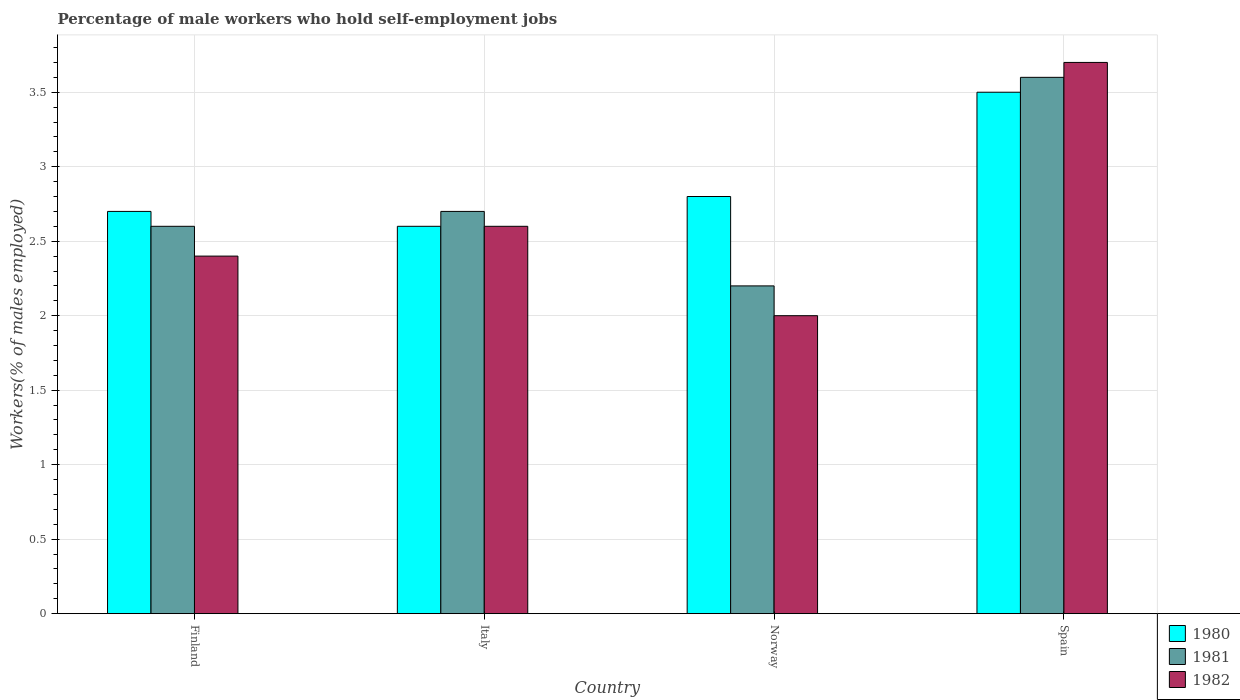How many different coloured bars are there?
Give a very brief answer. 3. Are the number of bars on each tick of the X-axis equal?
Ensure brevity in your answer.  Yes. What is the percentage of self-employed male workers in 1980 in Finland?
Offer a very short reply. 2.7. Across all countries, what is the maximum percentage of self-employed male workers in 1980?
Offer a very short reply. 3.5. Across all countries, what is the minimum percentage of self-employed male workers in 1980?
Your answer should be very brief. 2.6. In which country was the percentage of self-employed male workers in 1981 maximum?
Provide a succinct answer. Spain. What is the total percentage of self-employed male workers in 1982 in the graph?
Provide a short and direct response. 10.7. What is the difference between the percentage of self-employed male workers in 1981 in Italy and that in Spain?
Your answer should be compact. -0.9. What is the difference between the percentage of self-employed male workers in 1982 in Italy and the percentage of self-employed male workers in 1980 in Finland?
Provide a succinct answer. -0.1. What is the average percentage of self-employed male workers in 1982 per country?
Offer a very short reply. 2.68. What is the difference between the percentage of self-employed male workers of/in 1980 and percentage of self-employed male workers of/in 1982 in Finland?
Your answer should be very brief. 0.3. What is the ratio of the percentage of self-employed male workers in 1980 in Norway to that in Spain?
Keep it short and to the point. 0.8. Is the percentage of self-employed male workers in 1982 in Italy less than that in Norway?
Your response must be concise. No. What is the difference between the highest and the second highest percentage of self-employed male workers in 1980?
Give a very brief answer. -0.1. What is the difference between the highest and the lowest percentage of self-employed male workers in 1981?
Offer a terse response. 1.4. In how many countries, is the percentage of self-employed male workers in 1981 greater than the average percentage of self-employed male workers in 1981 taken over all countries?
Provide a succinct answer. 1. What does the 1st bar from the left in Spain represents?
Give a very brief answer. 1980. What does the 3rd bar from the right in Spain represents?
Ensure brevity in your answer.  1980. How many bars are there?
Your answer should be compact. 12. Are all the bars in the graph horizontal?
Your answer should be very brief. No. How many countries are there in the graph?
Your answer should be very brief. 4. What is the difference between two consecutive major ticks on the Y-axis?
Ensure brevity in your answer.  0.5. Are the values on the major ticks of Y-axis written in scientific E-notation?
Provide a short and direct response. No. Where does the legend appear in the graph?
Give a very brief answer. Bottom right. How are the legend labels stacked?
Provide a short and direct response. Vertical. What is the title of the graph?
Your answer should be compact. Percentage of male workers who hold self-employment jobs. Does "1972" appear as one of the legend labels in the graph?
Provide a succinct answer. No. What is the label or title of the Y-axis?
Keep it short and to the point. Workers(% of males employed). What is the Workers(% of males employed) in 1980 in Finland?
Offer a very short reply. 2.7. What is the Workers(% of males employed) of 1981 in Finland?
Provide a succinct answer. 2.6. What is the Workers(% of males employed) in 1982 in Finland?
Your answer should be very brief. 2.4. What is the Workers(% of males employed) of 1980 in Italy?
Your response must be concise. 2.6. What is the Workers(% of males employed) of 1981 in Italy?
Your answer should be compact. 2.7. What is the Workers(% of males employed) of 1982 in Italy?
Keep it short and to the point. 2.6. What is the Workers(% of males employed) in 1980 in Norway?
Give a very brief answer. 2.8. What is the Workers(% of males employed) in 1981 in Norway?
Offer a terse response. 2.2. What is the Workers(% of males employed) of 1982 in Norway?
Your answer should be compact. 2. What is the Workers(% of males employed) in 1981 in Spain?
Provide a short and direct response. 3.6. What is the Workers(% of males employed) in 1982 in Spain?
Your answer should be very brief. 3.7. Across all countries, what is the maximum Workers(% of males employed) in 1981?
Offer a terse response. 3.6. Across all countries, what is the maximum Workers(% of males employed) in 1982?
Keep it short and to the point. 3.7. Across all countries, what is the minimum Workers(% of males employed) of 1980?
Your answer should be compact. 2.6. Across all countries, what is the minimum Workers(% of males employed) in 1981?
Ensure brevity in your answer.  2.2. Across all countries, what is the minimum Workers(% of males employed) in 1982?
Your answer should be compact. 2. What is the total Workers(% of males employed) in 1981 in the graph?
Your answer should be very brief. 11.1. What is the total Workers(% of males employed) in 1982 in the graph?
Make the answer very short. 10.7. What is the difference between the Workers(% of males employed) in 1981 in Finland and that in Italy?
Keep it short and to the point. -0.1. What is the difference between the Workers(% of males employed) in 1980 in Finland and that in Norway?
Make the answer very short. -0.1. What is the difference between the Workers(% of males employed) in 1982 in Finland and that in Norway?
Your answer should be very brief. 0.4. What is the difference between the Workers(% of males employed) in 1980 in Finland and that in Spain?
Ensure brevity in your answer.  -0.8. What is the difference between the Workers(% of males employed) of 1981 in Finland and that in Spain?
Offer a very short reply. -1. What is the difference between the Workers(% of males employed) of 1982 in Finland and that in Spain?
Offer a terse response. -1.3. What is the difference between the Workers(% of males employed) in 1980 in Italy and that in Spain?
Your answer should be very brief. -0.9. What is the difference between the Workers(% of males employed) in 1981 in Italy and that in Spain?
Make the answer very short. -0.9. What is the difference between the Workers(% of males employed) of 1982 in Italy and that in Spain?
Provide a short and direct response. -1.1. What is the difference between the Workers(% of males employed) in 1980 in Norway and that in Spain?
Your answer should be very brief. -0.7. What is the difference between the Workers(% of males employed) of 1981 in Norway and that in Spain?
Give a very brief answer. -1.4. What is the difference between the Workers(% of males employed) in 1982 in Norway and that in Spain?
Your answer should be very brief. -1.7. What is the difference between the Workers(% of males employed) of 1980 in Finland and the Workers(% of males employed) of 1981 in Norway?
Your response must be concise. 0.5. What is the difference between the Workers(% of males employed) in 1980 in Finland and the Workers(% of males employed) in 1982 in Norway?
Offer a terse response. 0.7. What is the difference between the Workers(% of males employed) in 1981 in Finland and the Workers(% of males employed) in 1982 in Norway?
Provide a short and direct response. 0.6. What is the difference between the Workers(% of males employed) in 1980 in Finland and the Workers(% of males employed) in 1981 in Spain?
Your response must be concise. -0.9. What is the difference between the Workers(% of males employed) in 1980 in Finland and the Workers(% of males employed) in 1982 in Spain?
Keep it short and to the point. -1. What is the difference between the Workers(% of males employed) of 1981 in Italy and the Workers(% of males employed) of 1982 in Norway?
Keep it short and to the point. 0.7. What is the difference between the Workers(% of males employed) in 1981 in Italy and the Workers(% of males employed) in 1982 in Spain?
Offer a very short reply. -1. What is the difference between the Workers(% of males employed) in 1980 in Norway and the Workers(% of males employed) in 1981 in Spain?
Provide a succinct answer. -0.8. What is the difference between the Workers(% of males employed) in 1980 in Norway and the Workers(% of males employed) in 1982 in Spain?
Provide a succinct answer. -0.9. What is the difference between the Workers(% of males employed) in 1981 in Norway and the Workers(% of males employed) in 1982 in Spain?
Your answer should be compact. -1.5. What is the average Workers(% of males employed) of 1981 per country?
Provide a succinct answer. 2.77. What is the average Workers(% of males employed) of 1982 per country?
Ensure brevity in your answer.  2.67. What is the difference between the Workers(% of males employed) of 1980 and Workers(% of males employed) of 1982 in Finland?
Provide a succinct answer. 0.3. What is the difference between the Workers(% of males employed) of 1981 and Workers(% of males employed) of 1982 in Finland?
Offer a very short reply. 0.2. What is the difference between the Workers(% of males employed) of 1981 and Workers(% of males employed) of 1982 in Italy?
Give a very brief answer. 0.1. What is the difference between the Workers(% of males employed) of 1980 and Workers(% of males employed) of 1981 in Norway?
Offer a very short reply. 0.6. What is the difference between the Workers(% of males employed) in 1980 and Workers(% of males employed) in 1982 in Norway?
Give a very brief answer. 0.8. What is the difference between the Workers(% of males employed) of 1981 and Workers(% of males employed) of 1982 in Norway?
Your answer should be very brief. 0.2. What is the difference between the Workers(% of males employed) of 1980 and Workers(% of males employed) of 1981 in Spain?
Ensure brevity in your answer.  -0.1. What is the difference between the Workers(% of males employed) of 1981 and Workers(% of males employed) of 1982 in Spain?
Offer a terse response. -0.1. What is the ratio of the Workers(% of males employed) of 1982 in Finland to that in Italy?
Your answer should be very brief. 0.92. What is the ratio of the Workers(% of males employed) in 1981 in Finland to that in Norway?
Your response must be concise. 1.18. What is the ratio of the Workers(% of males employed) of 1982 in Finland to that in Norway?
Offer a very short reply. 1.2. What is the ratio of the Workers(% of males employed) of 1980 in Finland to that in Spain?
Keep it short and to the point. 0.77. What is the ratio of the Workers(% of males employed) of 1981 in Finland to that in Spain?
Your response must be concise. 0.72. What is the ratio of the Workers(% of males employed) in 1982 in Finland to that in Spain?
Keep it short and to the point. 0.65. What is the ratio of the Workers(% of males employed) of 1980 in Italy to that in Norway?
Your response must be concise. 0.93. What is the ratio of the Workers(% of males employed) in 1981 in Italy to that in Norway?
Offer a terse response. 1.23. What is the ratio of the Workers(% of males employed) of 1980 in Italy to that in Spain?
Provide a succinct answer. 0.74. What is the ratio of the Workers(% of males employed) in 1982 in Italy to that in Spain?
Make the answer very short. 0.7. What is the ratio of the Workers(% of males employed) in 1980 in Norway to that in Spain?
Offer a very short reply. 0.8. What is the ratio of the Workers(% of males employed) of 1981 in Norway to that in Spain?
Give a very brief answer. 0.61. What is the ratio of the Workers(% of males employed) in 1982 in Norway to that in Spain?
Your answer should be compact. 0.54. What is the difference between the highest and the second highest Workers(% of males employed) of 1980?
Offer a very short reply. 0.7. What is the difference between the highest and the second highest Workers(% of males employed) in 1982?
Your answer should be compact. 1.1. What is the difference between the highest and the lowest Workers(% of males employed) of 1981?
Your answer should be compact. 1.4. 